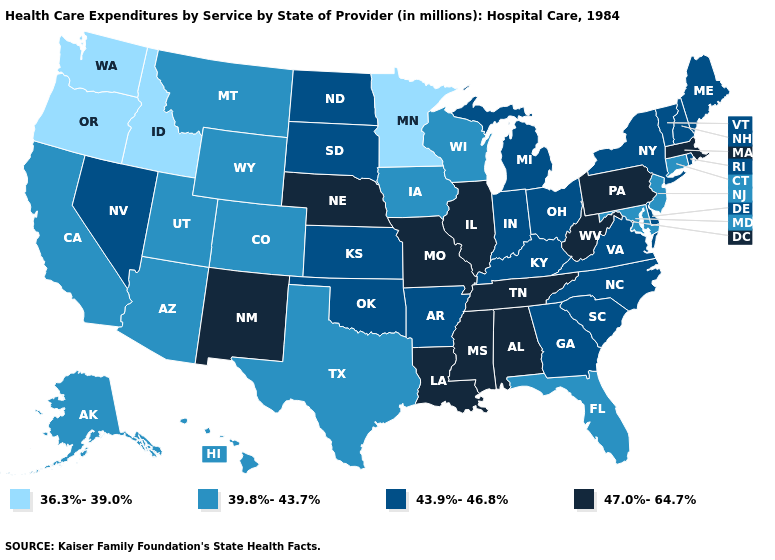What is the value of New Mexico?
Be succinct. 47.0%-64.7%. What is the value of Iowa?
Keep it brief. 39.8%-43.7%. What is the value of New Hampshire?
Short answer required. 43.9%-46.8%. What is the highest value in the Northeast ?
Short answer required. 47.0%-64.7%. Which states have the highest value in the USA?
Short answer required. Alabama, Illinois, Louisiana, Massachusetts, Mississippi, Missouri, Nebraska, New Mexico, Pennsylvania, Tennessee, West Virginia. Name the states that have a value in the range 36.3%-39.0%?
Short answer required. Idaho, Minnesota, Oregon, Washington. What is the highest value in the USA?
Give a very brief answer. 47.0%-64.7%. Which states have the highest value in the USA?
Concise answer only. Alabama, Illinois, Louisiana, Massachusetts, Mississippi, Missouri, Nebraska, New Mexico, Pennsylvania, Tennessee, West Virginia. Name the states that have a value in the range 36.3%-39.0%?
Short answer required. Idaho, Minnesota, Oregon, Washington. Name the states that have a value in the range 36.3%-39.0%?
Keep it brief. Idaho, Minnesota, Oregon, Washington. Does Montana have the same value as Ohio?
Concise answer only. No. Does the first symbol in the legend represent the smallest category?
Give a very brief answer. Yes. Among the states that border Idaho , does Montana have the lowest value?
Quick response, please. No. What is the value of Wisconsin?
Short answer required. 39.8%-43.7%. Does Delaware have the lowest value in the South?
Write a very short answer. No. 